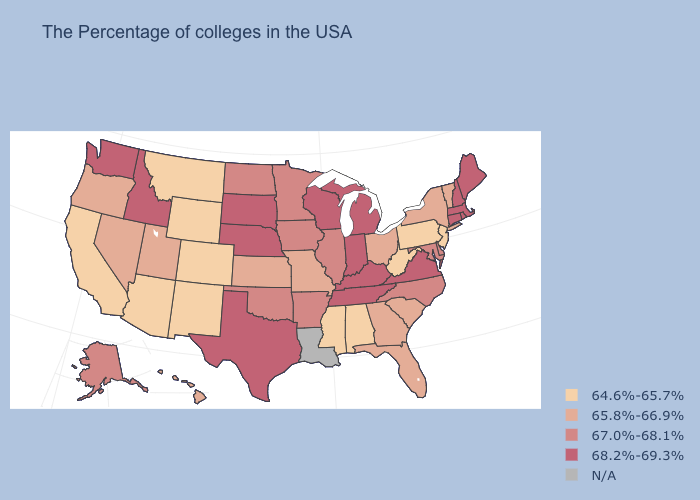What is the value of Arizona?
Keep it brief. 64.6%-65.7%. What is the value of Wyoming?
Short answer required. 64.6%-65.7%. How many symbols are there in the legend?
Write a very short answer. 5. Among the states that border Tennessee , does Virginia have the lowest value?
Give a very brief answer. No. What is the value of Connecticut?
Keep it brief. 68.2%-69.3%. Name the states that have a value in the range 68.2%-69.3%?
Quick response, please. Maine, Massachusetts, Rhode Island, New Hampshire, Connecticut, Virginia, Michigan, Kentucky, Indiana, Tennessee, Wisconsin, Nebraska, Texas, South Dakota, Idaho, Washington. Among the states that border Georgia , does Tennessee have the highest value?
Concise answer only. Yes. Does Vermont have the highest value in the Northeast?
Give a very brief answer. No. Is the legend a continuous bar?
Answer briefly. No. Does the map have missing data?
Short answer required. Yes. Does West Virginia have the lowest value in the South?
Short answer required. Yes. Name the states that have a value in the range 65.8%-66.9%?
Be succinct. Vermont, New York, South Carolina, Ohio, Florida, Georgia, Missouri, Kansas, Utah, Nevada, Oregon, Hawaii. Name the states that have a value in the range 64.6%-65.7%?
Answer briefly. New Jersey, Pennsylvania, West Virginia, Alabama, Mississippi, Wyoming, Colorado, New Mexico, Montana, Arizona, California. What is the highest value in the Northeast ?
Give a very brief answer. 68.2%-69.3%. 